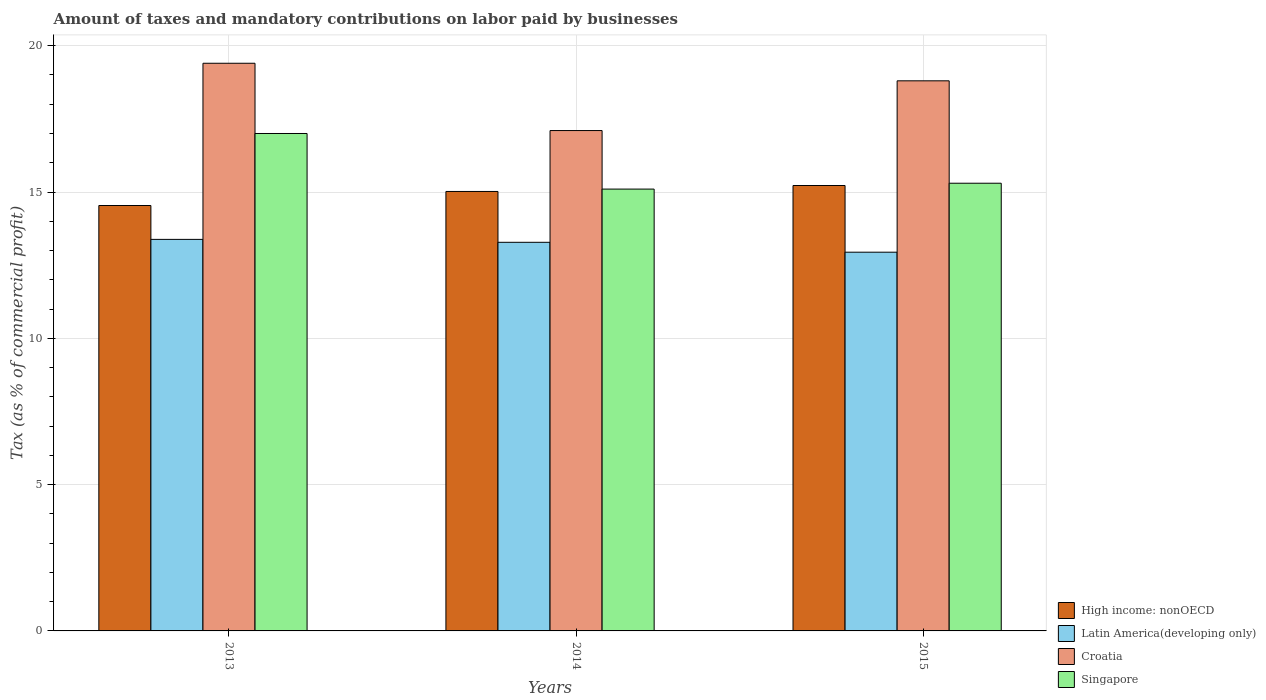How many different coloured bars are there?
Keep it short and to the point. 4. How many groups of bars are there?
Make the answer very short. 3. Are the number of bars per tick equal to the number of legend labels?
Your answer should be very brief. Yes. How many bars are there on the 2nd tick from the left?
Make the answer very short. 4. What is the label of the 1st group of bars from the left?
Make the answer very short. 2013. What is the percentage of taxes paid by businesses in High income: nonOECD in 2015?
Offer a very short reply. 15.22. Across all years, what is the maximum percentage of taxes paid by businesses in High income: nonOECD?
Make the answer very short. 15.22. Across all years, what is the minimum percentage of taxes paid by businesses in Singapore?
Make the answer very short. 15.1. In which year was the percentage of taxes paid by businesses in Latin America(developing only) minimum?
Your response must be concise. 2015. What is the total percentage of taxes paid by businesses in Latin America(developing only) in the graph?
Your answer should be compact. 39.6. What is the difference between the percentage of taxes paid by businesses in Latin America(developing only) in 2014 and that in 2015?
Your answer should be compact. 0.34. What is the difference between the percentage of taxes paid by businesses in Latin America(developing only) in 2014 and the percentage of taxes paid by businesses in Croatia in 2013?
Provide a succinct answer. -6.12. What is the average percentage of taxes paid by businesses in Croatia per year?
Provide a short and direct response. 18.43. In the year 2014, what is the difference between the percentage of taxes paid by businesses in High income: nonOECD and percentage of taxes paid by businesses in Latin America(developing only)?
Make the answer very short. 1.74. What is the ratio of the percentage of taxes paid by businesses in Latin America(developing only) in 2013 to that in 2014?
Your response must be concise. 1.01. What is the difference between the highest and the second highest percentage of taxes paid by businesses in Croatia?
Provide a short and direct response. 0.6. What is the difference between the highest and the lowest percentage of taxes paid by businesses in Latin America(developing only)?
Give a very brief answer. 0.44. Is the sum of the percentage of taxes paid by businesses in Singapore in 2013 and 2014 greater than the maximum percentage of taxes paid by businesses in Latin America(developing only) across all years?
Provide a succinct answer. Yes. What does the 2nd bar from the left in 2015 represents?
Your answer should be very brief. Latin America(developing only). What does the 3rd bar from the right in 2013 represents?
Offer a terse response. Latin America(developing only). Is it the case that in every year, the sum of the percentage of taxes paid by businesses in Croatia and percentage of taxes paid by businesses in Singapore is greater than the percentage of taxes paid by businesses in Latin America(developing only)?
Make the answer very short. Yes. How many bars are there?
Ensure brevity in your answer.  12. How many years are there in the graph?
Your answer should be very brief. 3. Are the values on the major ticks of Y-axis written in scientific E-notation?
Your response must be concise. No. Where does the legend appear in the graph?
Offer a terse response. Bottom right. What is the title of the graph?
Give a very brief answer. Amount of taxes and mandatory contributions on labor paid by businesses. Does "United Arab Emirates" appear as one of the legend labels in the graph?
Your response must be concise. No. What is the label or title of the X-axis?
Keep it short and to the point. Years. What is the label or title of the Y-axis?
Offer a very short reply. Tax (as % of commercial profit). What is the Tax (as % of commercial profit) in High income: nonOECD in 2013?
Give a very brief answer. 14.54. What is the Tax (as % of commercial profit) of Latin America(developing only) in 2013?
Ensure brevity in your answer.  13.38. What is the Tax (as % of commercial profit) of Croatia in 2013?
Ensure brevity in your answer.  19.4. What is the Tax (as % of commercial profit) in Singapore in 2013?
Provide a short and direct response. 17. What is the Tax (as % of commercial profit) in High income: nonOECD in 2014?
Provide a succinct answer. 15.02. What is the Tax (as % of commercial profit) in Latin America(developing only) in 2014?
Your answer should be very brief. 13.28. What is the Tax (as % of commercial profit) in High income: nonOECD in 2015?
Offer a very short reply. 15.22. What is the Tax (as % of commercial profit) of Latin America(developing only) in 2015?
Keep it short and to the point. 12.94. What is the Tax (as % of commercial profit) in Croatia in 2015?
Offer a terse response. 18.8. Across all years, what is the maximum Tax (as % of commercial profit) of High income: nonOECD?
Make the answer very short. 15.22. Across all years, what is the maximum Tax (as % of commercial profit) in Latin America(developing only)?
Give a very brief answer. 13.38. Across all years, what is the maximum Tax (as % of commercial profit) of Croatia?
Give a very brief answer. 19.4. Across all years, what is the maximum Tax (as % of commercial profit) in Singapore?
Ensure brevity in your answer.  17. Across all years, what is the minimum Tax (as % of commercial profit) in High income: nonOECD?
Your response must be concise. 14.54. Across all years, what is the minimum Tax (as % of commercial profit) of Latin America(developing only)?
Offer a terse response. 12.94. Across all years, what is the minimum Tax (as % of commercial profit) of Singapore?
Provide a short and direct response. 15.1. What is the total Tax (as % of commercial profit) in High income: nonOECD in the graph?
Offer a terse response. 44.78. What is the total Tax (as % of commercial profit) in Latin America(developing only) in the graph?
Make the answer very short. 39.6. What is the total Tax (as % of commercial profit) in Croatia in the graph?
Give a very brief answer. 55.3. What is the total Tax (as % of commercial profit) in Singapore in the graph?
Provide a succinct answer. 47.4. What is the difference between the Tax (as % of commercial profit) in High income: nonOECD in 2013 and that in 2014?
Your response must be concise. -0.48. What is the difference between the Tax (as % of commercial profit) in Latin America(developing only) in 2013 and that in 2014?
Offer a terse response. 0.1. What is the difference between the Tax (as % of commercial profit) in High income: nonOECD in 2013 and that in 2015?
Provide a succinct answer. -0.68. What is the difference between the Tax (as % of commercial profit) of Latin America(developing only) in 2013 and that in 2015?
Offer a terse response. 0.44. What is the difference between the Tax (as % of commercial profit) of Croatia in 2013 and that in 2015?
Provide a short and direct response. 0.6. What is the difference between the Tax (as % of commercial profit) of High income: nonOECD in 2014 and that in 2015?
Your response must be concise. -0.2. What is the difference between the Tax (as % of commercial profit) of Latin America(developing only) in 2014 and that in 2015?
Offer a terse response. 0.34. What is the difference between the Tax (as % of commercial profit) of Croatia in 2014 and that in 2015?
Keep it short and to the point. -1.7. What is the difference between the Tax (as % of commercial profit) of High income: nonOECD in 2013 and the Tax (as % of commercial profit) of Latin America(developing only) in 2014?
Keep it short and to the point. 1.26. What is the difference between the Tax (as % of commercial profit) in High income: nonOECD in 2013 and the Tax (as % of commercial profit) in Croatia in 2014?
Offer a very short reply. -2.56. What is the difference between the Tax (as % of commercial profit) in High income: nonOECD in 2013 and the Tax (as % of commercial profit) in Singapore in 2014?
Provide a short and direct response. -0.56. What is the difference between the Tax (as % of commercial profit) in Latin America(developing only) in 2013 and the Tax (as % of commercial profit) in Croatia in 2014?
Your answer should be compact. -3.72. What is the difference between the Tax (as % of commercial profit) of Latin America(developing only) in 2013 and the Tax (as % of commercial profit) of Singapore in 2014?
Provide a succinct answer. -1.72. What is the difference between the Tax (as % of commercial profit) in Croatia in 2013 and the Tax (as % of commercial profit) in Singapore in 2014?
Your answer should be compact. 4.3. What is the difference between the Tax (as % of commercial profit) in High income: nonOECD in 2013 and the Tax (as % of commercial profit) in Latin America(developing only) in 2015?
Your response must be concise. 1.6. What is the difference between the Tax (as % of commercial profit) of High income: nonOECD in 2013 and the Tax (as % of commercial profit) of Croatia in 2015?
Give a very brief answer. -4.26. What is the difference between the Tax (as % of commercial profit) of High income: nonOECD in 2013 and the Tax (as % of commercial profit) of Singapore in 2015?
Provide a succinct answer. -0.76. What is the difference between the Tax (as % of commercial profit) of Latin America(developing only) in 2013 and the Tax (as % of commercial profit) of Croatia in 2015?
Provide a succinct answer. -5.42. What is the difference between the Tax (as % of commercial profit) of Latin America(developing only) in 2013 and the Tax (as % of commercial profit) of Singapore in 2015?
Ensure brevity in your answer.  -1.92. What is the difference between the Tax (as % of commercial profit) of High income: nonOECD in 2014 and the Tax (as % of commercial profit) of Latin America(developing only) in 2015?
Make the answer very short. 2.08. What is the difference between the Tax (as % of commercial profit) of High income: nonOECD in 2014 and the Tax (as % of commercial profit) of Croatia in 2015?
Provide a succinct answer. -3.78. What is the difference between the Tax (as % of commercial profit) in High income: nonOECD in 2014 and the Tax (as % of commercial profit) in Singapore in 2015?
Your answer should be very brief. -0.28. What is the difference between the Tax (as % of commercial profit) in Latin America(developing only) in 2014 and the Tax (as % of commercial profit) in Croatia in 2015?
Provide a succinct answer. -5.52. What is the difference between the Tax (as % of commercial profit) of Latin America(developing only) in 2014 and the Tax (as % of commercial profit) of Singapore in 2015?
Ensure brevity in your answer.  -2.02. What is the difference between the Tax (as % of commercial profit) of Croatia in 2014 and the Tax (as % of commercial profit) of Singapore in 2015?
Ensure brevity in your answer.  1.8. What is the average Tax (as % of commercial profit) of High income: nonOECD per year?
Provide a short and direct response. 14.93. What is the average Tax (as % of commercial profit) of Latin America(developing only) per year?
Offer a terse response. 13.2. What is the average Tax (as % of commercial profit) of Croatia per year?
Keep it short and to the point. 18.43. What is the average Tax (as % of commercial profit) in Singapore per year?
Make the answer very short. 15.8. In the year 2013, what is the difference between the Tax (as % of commercial profit) in High income: nonOECD and Tax (as % of commercial profit) in Latin America(developing only)?
Make the answer very short. 1.16. In the year 2013, what is the difference between the Tax (as % of commercial profit) in High income: nonOECD and Tax (as % of commercial profit) in Croatia?
Provide a short and direct response. -4.86. In the year 2013, what is the difference between the Tax (as % of commercial profit) of High income: nonOECD and Tax (as % of commercial profit) of Singapore?
Make the answer very short. -2.46. In the year 2013, what is the difference between the Tax (as % of commercial profit) of Latin America(developing only) and Tax (as % of commercial profit) of Croatia?
Make the answer very short. -6.02. In the year 2013, what is the difference between the Tax (as % of commercial profit) in Latin America(developing only) and Tax (as % of commercial profit) in Singapore?
Provide a short and direct response. -3.62. In the year 2014, what is the difference between the Tax (as % of commercial profit) of High income: nonOECD and Tax (as % of commercial profit) of Latin America(developing only)?
Your response must be concise. 1.74. In the year 2014, what is the difference between the Tax (as % of commercial profit) in High income: nonOECD and Tax (as % of commercial profit) in Croatia?
Provide a short and direct response. -2.08. In the year 2014, what is the difference between the Tax (as % of commercial profit) of High income: nonOECD and Tax (as % of commercial profit) of Singapore?
Provide a short and direct response. -0.08. In the year 2014, what is the difference between the Tax (as % of commercial profit) in Latin America(developing only) and Tax (as % of commercial profit) in Croatia?
Your answer should be very brief. -3.82. In the year 2014, what is the difference between the Tax (as % of commercial profit) of Latin America(developing only) and Tax (as % of commercial profit) of Singapore?
Offer a terse response. -1.82. In the year 2014, what is the difference between the Tax (as % of commercial profit) of Croatia and Tax (as % of commercial profit) of Singapore?
Offer a very short reply. 2. In the year 2015, what is the difference between the Tax (as % of commercial profit) of High income: nonOECD and Tax (as % of commercial profit) of Latin America(developing only)?
Ensure brevity in your answer.  2.28. In the year 2015, what is the difference between the Tax (as % of commercial profit) of High income: nonOECD and Tax (as % of commercial profit) of Croatia?
Offer a terse response. -3.58. In the year 2015, what is the difference between the Tax (as % of commercial profit) in High income: nonOECD and Tax (as % of commercial profit) in Singapore?
Offer a very short reply. -0.08. In the year 2015, what is the difference between the Tax (as % of commercial profit) in Latin America(developing only) and Tax (as % of commercial profit) in Croatia?
Your answer should be compact. -5.86. In the year 2015, what is the difference between the Tax (as % of commercial profit) in Latin America(developing only) and Tax (as % of commercial profit) in Singapore?
Provide a short and direct response. -2.36. In the year 2015, what is the difference between the Tax (as % of commercial profit) of Croatia and Tax (as % of commercial profit) of Singapore?
Ensure brevity in your answer.  3.5. What is the ratio of the Tax (as % of commercial profit) in High income: nonOECD in 2013 to that in 2014?
Ensure brevity in your answer.  0.97. What is the ratio of the Tax (as % of commercial profit) in Latin America(developing only) in 2013 to that in 2014?
Offer a terse response. 1.01. What is the ratio of the Tax (as % of commercial profit) of Croatia in 2013 to that in 2014?
Offer a terse response. 1.13. What is the ratio of the Tax (as % of commercial profit) in Singapore in 2013 to that in 2014?
Keep it short and to the point. 1.13. What is the ratio of the Tax (as % of commercial profit) in High income: nonOECD in 2013 to that in 2015?
Give a very brief answer. 0.96. What is the ratio of the Tax (as % of commercial profit) of Latin America(developing only) in 2013 to that in 2015?
Your answer should be compact. 1.03. What is the ratio of the Tax (as % of commercial profit) in Croatia in 2013 to that in 2015?
Make the answer very short. 1.03. What is the ratio of the Tax (as % of commercial profit) of High income: nonOECD in 2014 to that in 2015?
Your response must be concise. 0.99. What is the ratio of the Tax (as % of commercial profit) of Latin America(developing only) in 2014 to that in 2015?
Your answer should be compact. 1.03. What is the ratio of the Tax (as % of commercial profit) in Croatia in 2014 to that in 2015?
Offer a terse response. 0.91. What is the ratio of the Tax (as % of commercial profit) of Singapore in 2014 to that in 2015?
Give a very brief answer. 0.99. What is the difference between the highest and the second highest Tax (as % of commercial profit) in High income: nonOECD?
Provide a short and direct response. 0.2. What is the difference between the highest and the second highest Tax (as % of commercial profit) in Latin America(developing only)?
Ensure brevity in your answer.  0.1. What is the difference between the highest and the second highest Tax (as % of commercial profit) in Croatia?
Give a very brief answer. 0.6. What is the difference between the highest and the lowest Tax (as % of commercial profit) in High income: nonOECD?
Offer a very short reply. 0.68. What is the difference between the highest and the lowest Tax (as % of commercial profit) in Latin America(developing only)?
Make the answer very short. 0.44. What is the difference between the highest and the lowest Tax (as % of commercial profit) of Croatia?
Keep it short and to the point. 2.3. 